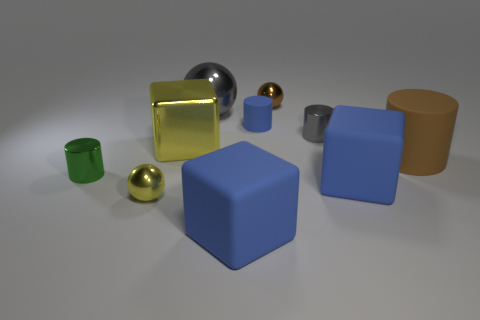Subtract all big blue matte blocks. How many blocks are left? 1 Subtract all cyan balls. How many blue cubes are left? 2 Subtract all yellow balls. How many balls are left? 2 Subtract all cylinders. How many objects are left? 6 Subtract 0 cyan cylinders. How many objects are left? 10 Subtract 3 cylinders. How many cylinders are left? 1 Subtract all red spheres. Subtract all purple cylinders. How many spheres are left? 3 Subtract all blue cubes. Subtract all small yellow shiny spheres. How many objects are left? 7 Add 6 gray metallic cylinders. How many gray metallic cylinders are left? 7 Add 3 small gray objects. How many small gray objects exist? 4 